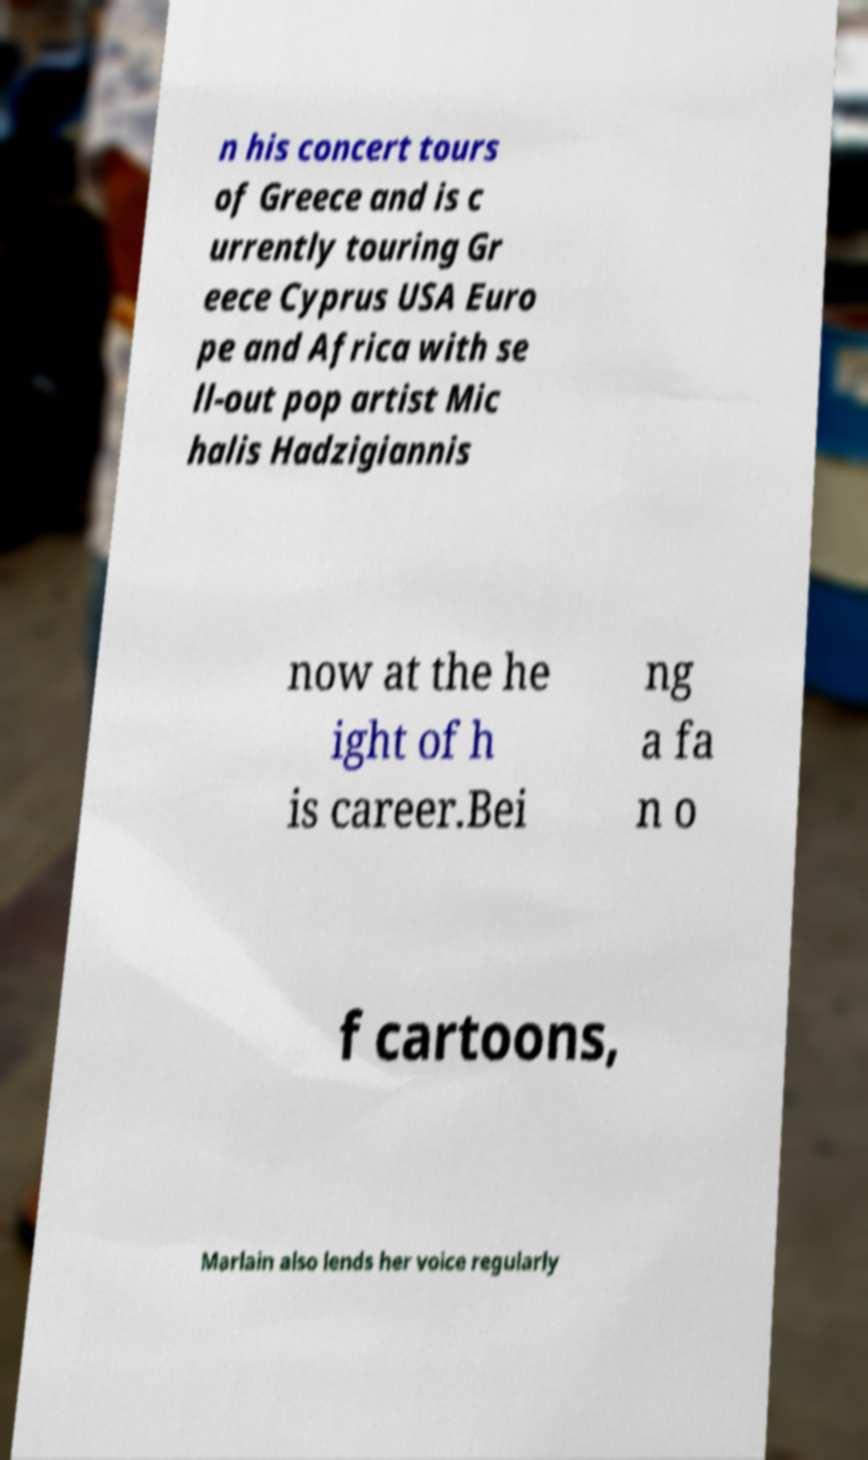There's text embedded in this image that I need extracted. Can you transcribe it verbatim? n his concert tours of Greece and is c urrently touring Gr eece Cyprus USA Euro pe and Africa with se ll-out pop artist Mic halis Hadzigiannis now at the he ight of h is career.Bei ng a fa n o f cartoons, Marlain also lends her voice regularly 